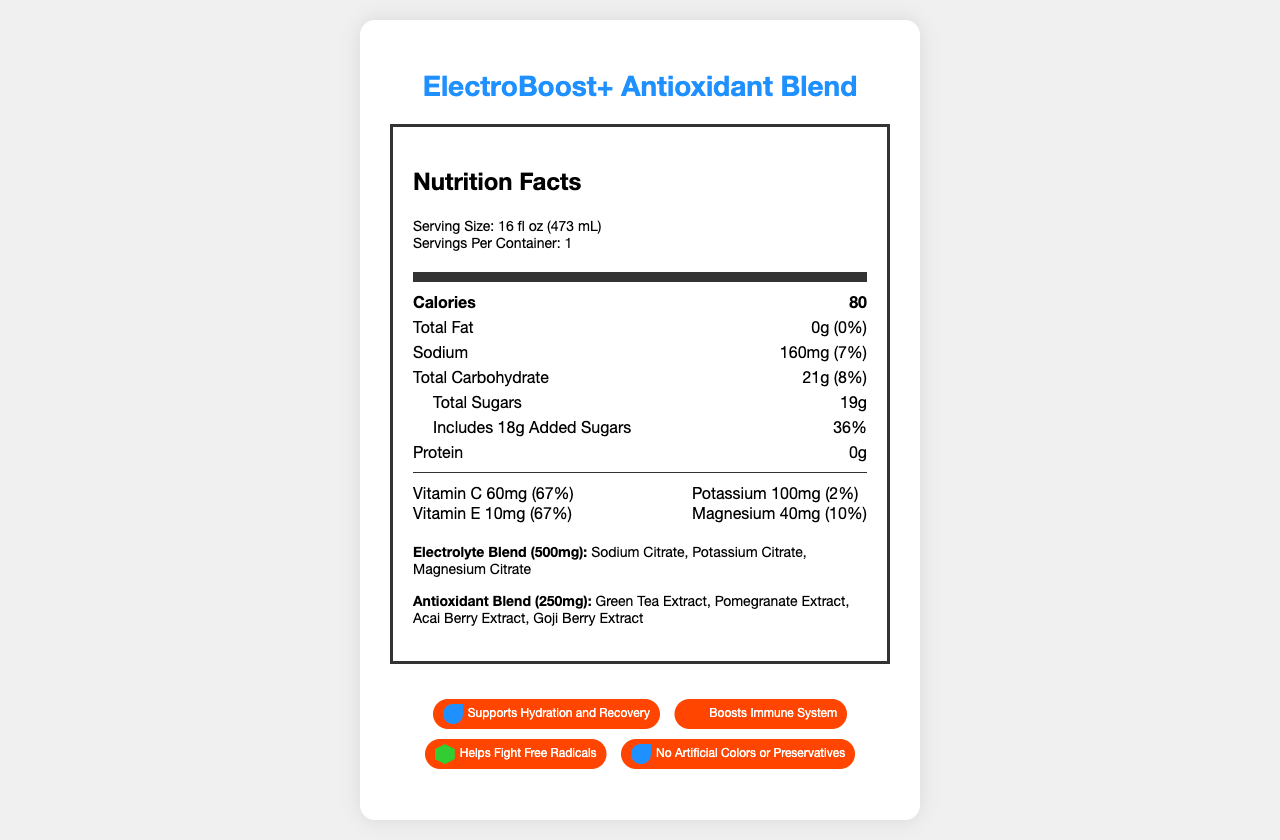what is the serving size for ElectroBoost+ Antioxidant Blend? The serving size is clearly indicated in the Nutrition Facts section as "Serving Size: 16 fl oz (473 mL)".
Answer: 16 fl oz (473 mL) How many calories are in one serving of ElectroBoost+ Antioxidant Blend? In the Nutrition Facts section, the number of calories per serving is listed as 80.
Answer: 80 What percentage of the daily value for vitamin C is provided in one serving? The Nutrition Facts label indicates that one serving provides 67% of the daily value for vitamin C.
Answer: 67% What is the unique selling proposition of ElectroBoost+ Antioxidant Blend? This is listed under the competitive analysis section as the unique selling proposition.
Answer: Premium electrolyte and antioxidant blend with natural ingredients for optimal hydration and recovery Name two ingredients in the ElectroBoost+ Antioxidant Blend's proprietary antioxidant blend. The antioxidant blend ingredients are listed as "Green Tea Extract, Pomegranate Extract, Acai Berry Extract, Goji Berry Extract".
Answer: Green Tea Extract, Pomegranate Extract What is the primary color used for the design elements? The primary color is specified under the design_elements section.
Answer: #1E90FF Which of the following is NOT a marketing claim made for ElectroBoost+ Antioxidant Blend? A. Supports Hydration and Recovery B. Increases Energy Levels C. Boosts Immune System D. Helps Fight Free Radicals "Boosts Immune System", "Supports Hydration and Recovery" and "Helps Fight Free Radicals" are listed as marketing claims; "Increases Energy Levels" is not.
Answer: B What is the daily value percentage of magnesium in one serving? A. 2% B. 7% C. 10% D. 36% The Nutrition Facts label shows that magnesium in one serving equals 10% of the daily value.
Answer: C Does the ElectroBoost+ Antioxidant Blend contain artificial colors? One of the listed marketing claims mentions that the product contains "No Artificial Colors or Preservatives".
Answer: No Summarize the main features highlighted in the ElectroBoost+ Antioxidant Blend's Nutrition Facts Label. The beverage boasts several health benefits, including hydration, immune support and antioxidant properties, all delivered without artificial colors or preservatives in an eye-catching design with key nutrients for recovery.
Answer: ElectroBoost+ Antioxidant Blend features a well-balanced nutritional profile aimed at health-conscious active adults. It includes 80 calories per serving, 21g total carbohydrates, 19g total sugars with 18g added sugars, and no fat or protein. It is particularly rich in vitamin C and E, and contains magnesium and potassium as electrolytes. The beverage boasts proprietary electrolyte and antioxidant blends with ingredients such as sodium and potassium citrate, green tea and pomegranate extract. It supports hydration, recovery, boosts the immune system, and fights free radicals, with no artificial colors or preservatives. The design is visually appealing with a focus on vibrant colors and modern icons. How does the serving size of ElectroBoost+ compare to typical sports drinks? The document does not provide specific serving sizes of typical sports drinks for comparison.
Answer: Not enough information 